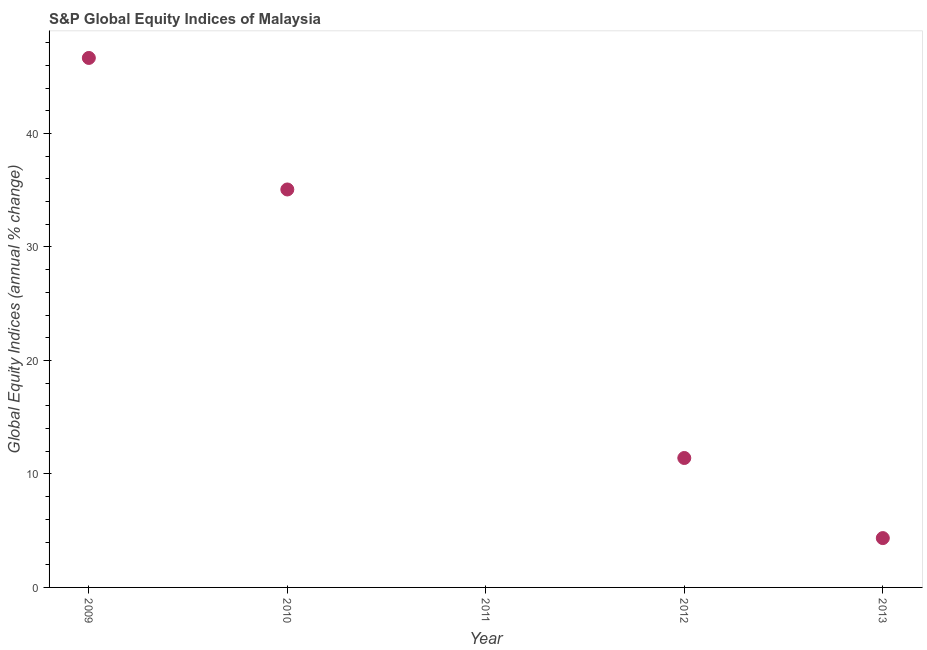What is the s&p global equity indices in 2010?
Your response must be concise. 35.06. Across all years, what is the maximum s&p global equity indices?
Your answer should be compact. 46.65. Across all years, what is the minimum s&p global equity indices?
Make the answer very short. 0. In which year was the s&p global equity indices maximum?
Provide a succinct answer. 2009. What is the sum of the s&p global equity indices?
Offer a very short reply. 97.47. What is the difference between the s&p global equity indices in 2010 and 2012?
Offer a very short reply. 23.66. What is the average s&p global equity indices per year?
Your answer should be very brief. 19.49. What is the median s&p global equity indices?
Make the answer very short. 11.4. What is the ratio of the s&p global equity indices in 2012 to that in 2013?
Provide a short and direct response. 2.62. Is the s&p global equity indices in 2009 less than that in 2012?
Provide a short and direct response. No. Is the difference between the s&p global equity indices in 2009 and 2010 greater than the difference between any two years?
Your answer should be compact. No. What is the difference between the highest and the second highest s&p global equity indices?
Make the answer very short. 11.59. What is the difference between the highest and the lowest s&p global equity indices?
Your answer should be very brief. 46.65. Are the values on the major ticks of Y-axis written in scientific E-notation?
Your answer should be compact. No. What is the title of the graph?
Offer a terse response. S&P Global Equity Indices of Malaysia. What is the label or title of the X-axis?
Offer a terse response. Year. What is the label or title of the Y-axis?
Ensure brevity in your answer.  Global Equity Indices (annual % change). What is the Global Equity Indices (annual % change) in 2009?
Your answer should be compact. 46.65. What is the Global Equity Indices (annual % change) in 2010?
Provide a succinct answer. 35.06. What is the Global Equity Indices (annual % change) in 2011?
Provide a short and direct response. 0. What is the Global Equity Indices (annual % change) in 2012?
Provide a succinct answer. 11.4. What is the Global Equity Indices (annual % change) in 2013?
Provide a succinct answer. 4.35. What is the difference between the Global Equity Indices (annual % change) in 2009 and 2010?
Ensure brevity in your answer.  11.59. What is the difference between the Global Equity Indices (annual % change) in 2009 and 2012?
Offer a very short reply. 35.25. What is the difference between the Global Equity Indices (annual % change) in 2009 and 2013?
Offer a very short reply. 42.31. What is the difference between the Global Equity Indices (annual % change) in 2010 and 2012?
Offer a very short reply. 23.66. What is the difference between the Global Equity Indices (annual % change) in 2010 and 2013?
Provide a succinct answer. 30.72. What is the difference between the Global Equity Indices (annual % change) in 2012 and 2013?
Provide a short and direct response. 7.06. What is the ratio of the Global Equity Indices (annual % change) in 2009 to that in 2010?
Provide a short and direct response. 1.33. What is the ratio of the Global Equity Indices (annual % change) in 2009 to that in 2012?
Your answer should be very brief. 4.09. What is the ratio of the Global Equity Indices (annual % change) in 2009 to that in 2013?
Provide a short and direct response. 10.73. What is the ratio of the Global Equity Indices (annual % change) in 2010 to that in 2012?
Give a very brief answer. 3.08. What is the ratio of the Global Equity Indices (annual % change) in 2010 to that in 2013?
Offer a terse response. 8.07. What is the ratio of the Global Equity Indices (annual % change) in 2012 to that in 2013?
Give a very brief answer. 2.62. 